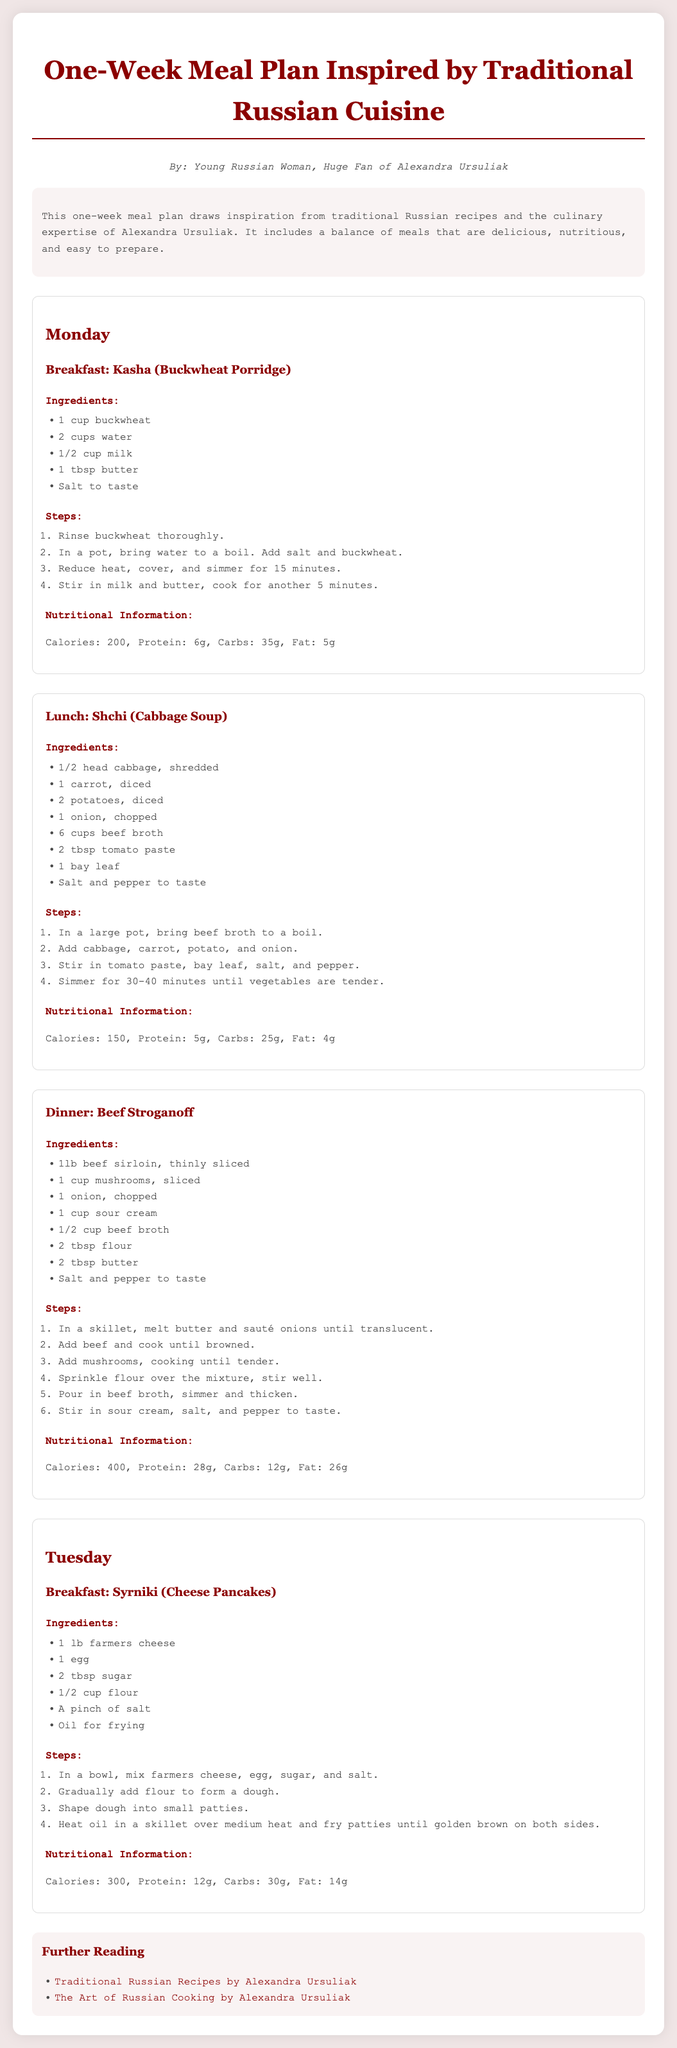What is the title of the document? The title of the document is presented at the top and describes the content.
Answer: One-Week Meal Plan Inspired by Traditional Russian Cuisine Who is the author of this document? The author is mentioned in the introductory section.
Answer: Young Russian Woman, Huge Fan of Alexandra Ursuliak How many meals are planned for Monday? The document lists the meals scheduled for Monday.
Answer: Three What is the main ingredient in Kasha? Kasha is identified in the breakfast section as having a specific main ingredient.
Answer: Buckwheat How long should Shchi be simmered? The instructions for Shchi specify the cooking time for the soup.
Answer: 30-40 minutes What is the nutritional information for Beef Stroganoff? The nutritional details are provided under the section for Beef Stroganoff.
Answer: Calories: 400, Protein: 28g, Carbs: 12g, Fat: 26g What cooking method is used for Syrniki? The method for preparing Syrniki is mentioned in the steps section.
Answer: Frying Which meal provides the highest calorie count? The meals include caloric information, allowing for a comparison.
Answer: Beef Stroganoff 